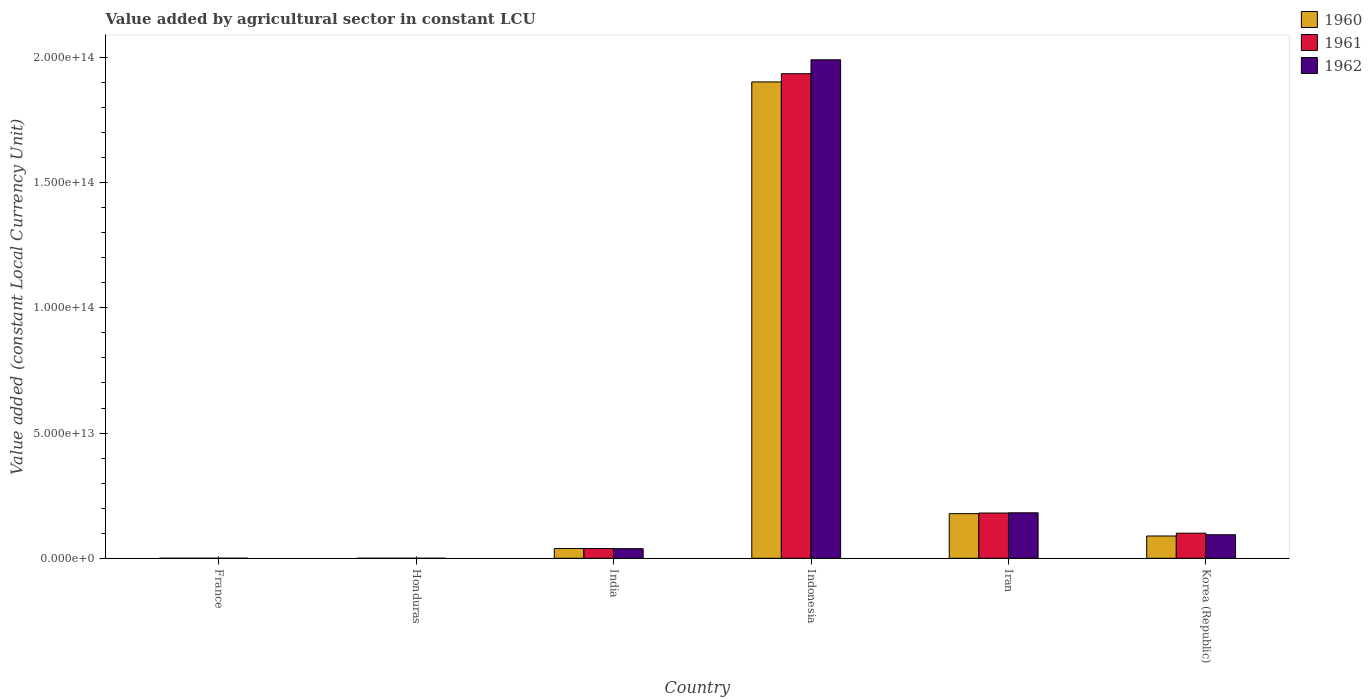How many different coloured bars are there?
Your answer should be compact. 3. How many bars are there on the 2nd tick from the right?
Give a very brief answer. 3. What is the value added by agricultural sector in 1960 in Korea (Republic)?
Keep it short and to the point. 8.90e+12. Across all countries, what is the maximum value added by agricultural sector in 1960?
Your answer should be very brief. 1.90e+14. Across all countries, what is the minimum value added by agricultural sector in 1962?
Provide a short and direct response. 4.96e+09. In which country was the value added by agricultural sector in 1961 minimum?
Keep it short and to the point. Honduras. What is the total value added by agricultural sector in 1961 in the graph?
Ensure brevity in your answer.  2.26e+14. What is the difference between the value added by agricultural sector in 1961 in Honduras and that in India?
Offer a very short reply. -3.90e+12. What is the difference between the value added by agricultural sector in 1961 in India and the value added by agricultural sector in 1960 in Honduras?
Give a very brief answer. 3.90e+12. What is the average value added by agricultural sector in 1961 per country?
Make the answer very short. 3.76e+13. What is the difference between the value added by agricultural sector of/in 1961 and value added by agricultural sector of/in 1962 in Honduras?
Your answer should be very brief. -2.25e+08. What is the ratio of the value added by agricultural sector in 1962 in France to that in Iran?
Offer a terse response. 0. Is the difference between the value added by agricultural sector in 1961 in Honduras and Iran greater than the difference between the value added by agricultural sector in 1962 in Honduras and Iran?
Your response must be concise. Yes. What is the difference between the highest and the second highest value added by agricultural sector in 1962?
Your answer should be very brief. -8.77e+12. What is the difference between the highest and the lowest value added by agricultural sector in 1960?
Make the answer very short. 1.90e+14. What does the 3rd bar from the right in India represents?
Offer a very short reply. 1960. Is it the case that in every country, the sum of the value added by agricultural sector in 1961 and value added by agricultural sector in 1962 is greater than the value added by agricultural sector in 1960?
Offer a terse response. Yes. How many countries are there in the graph?
Give a very brief answer. 6. What is the difference between two consecutive major ticks on the Y-axis?
Provide a succinct answer. 5.00e+13. Does the graph contain any zero values?
Your response must be concise. No. How are the legend labels stacked?
Ensure brevity in your answer.  Vertical. What is the title of the graph?
Keep it short and to the point. Value added by agricultural sector in constant LCU. What is the label or title of the Y-axis?
Offer a very short reply. Value added (constant Local Currency Unit). What is the Value added (constant Local Currency Unit) of 1960 in France?
Provide a short and direct response. 1.32e+1. What is the Value added (constant Local Currency Unit) in 1961 in France?
Offer a terse response. 1.25e+1. What is the Value added (constant Local Currency Unit) in 1962 in France?
Make the answer very short. 1.36e+1. What is the Value added (constant Local Currency Unit) in 1960 in Honduras?
Offer a very short reply. 4.44e+09. What is the Value added (constant Local Currency Unit) of 1961 in Honduras?
Keep it short and to the point. 4.73e+09. What is the Value added (constant Local Currency Unit) in 1962 in Honduras?
Provide a succinct answer. 4.96e+09. What is the Value added (constant Local Currency Unit) in 1960 in India?
Give a very brief answer. 3.90e+12. What is the Value added (constant Local Currency Unit) in 1961 in India?
Offer a very short reply. 3.91e+12. What is the Value added (constant Local Currency Unit) of 1962 in India?
Keep it short and to the point. 3.83e+12. What is the Value added (constant Local Currency Unit) of 1960 in Indonesia?
Give a very brief answer. 1.90e+14. What is the Value added (constant Local Currency Unit) of 1961 in Indonesia?
Keep it short and to the point. 1.94e+14. What is the Value added (constant Local Currency Unit) in 1962 in Indonesia?
Your response must be concise. 1.99e+14. What is the Value added (constant Local Currency Unit) in 1960 in Iran?
Your response must be concise. 1.78e+13. What is the Value added (constant Local Currency Unit) of 1961 in Iran?
Keep it short and to the point. 1.81e+13. What is the Value added (constant Local Currency Unit) of 1962 in Iran?
Keep it short and to the point. 1.82e+13. What is the Value added (constant Local Currency Unit) of 1960 in Korea (Republic)?
Provide a succinct answer. 8.90e+12. What is the Value added (constant Local Currency Unit) in 1961 in Korea (Republic)?
Your answer should be very brief. 1.00e+13. What is the Value added (constant Local Currency Unit) of 1962 in Korea (Republic)?
Keep it short and to the point. 9.39e+12. Across all countries, what is the maximum Value added (constant Local Currency Unit) in 1960?
Provide a succinct answer. 1.90e+14. Across all countries, what is the maximum Value added (constant Local Currency Unit) of 1961?
Your response must be concise. 1.94e+14. Across all countries, what is the maximum Value added (constant Local Currency Unit) of 1962?
Provide a short and direct response. 1.99e+14. Across all countries, what is the minimum Value added (constant Local Currency Unit) of 1960?
Provide a succinct answer. 4.44e+09. Across all countries, what is the minimum Value added (constant Local Currency Unit) of 1961?
Make the answer very short. 4.73e+09. Across all countries, what is the minimum Value added (constant Local Currency Unit) in 1962?
Make the answer very short. 4.96e+09. What is the total Value added (constant Local Currency Unit) in 1960 in the graph?
Provide a short and direct response. 2.21e+14. What is the total Value added (constant Local Currency Unit) in 1961 in the graph?
Offer a terse response. 2.26e+14. What is the total Value added (constant Local Currency Unit) of 1962 in the graph?
Make the answer very short. 2.30e+14. What is the difference between the Value added (constant Local Currency Unit) in 1960 in France and that in Honduras?
Ensure brevity in your answer.  8.72e+09. What is the difference between the Value added (constant Local Currency Unit) of 1961 in France and that in Honduras?
Offer a terse response. 7.74e+09. What is the difference between the Value added (constant Local Currency Unit) of 1962 in France and that in Honduras?
Keep it short and to the point. 8.63e+09. What is the difference between the Value added (constant Local Currency Unit) in 1960 in France and that in India?
Offer a terse response. -3.89e+12. What is the difference between the Value added (constant Local Currency Unit) of 1961 in France and that in India?
Make the answer very short. -3.90e+12. What is the difference between the Value added (constant Local Currency Unit) in 1962 in France and that in India?
Offer a very short reply. -3.82e+12. What is the difference between the Value added (constant Local Currency Unit) of 1960 in France and that in Indonesia?
Give a very brief answer. -1.90e+14. What is the difference between the Value added (constant Local Currency Unit) in 1961 in France and that in Indonesia?
Offer a very short reply. -1.94e+14. What is the difference between the Value added (constant Local Currency Unit) of 1962 in France and that in Indonesia?
Give a very brief answer. -1.99e+14. What is the difference between the Value added (constant Local Currency Unit) of 1960 in France and that in Iran?
Ensure brevity in your answer.  -1.78e+13. What is the difference between the Value added (constant Local Currency Unit) of 1961 in France and that in Iran?
Your response must be concise. -1.81e+13. What is the difference between the Value added (constant Local Currency Unit) in 1962 in France and that in Iran?
Give a very brief answer. -1.81e+13. What is the difference between the Value added (constant Local Currency Unit) in 1960 in France and that in Korea (Republic)?
Your response must be concise. -8.88e+12. What is the difference between the Value added (constant Local Currency Unit) of 1961 in France and that in Korea (Republic)?
Provide a short and direct response. -1.00e+13. What is the difference between the Value added (constant Local Currency Unit) in 1962 in France and that in Korea (Republic)?
Offer a terse response. -9.38e+12. What is the difference between the Value added (constant Local Currency Unit) in 1960 in Honduras and that in India?
Ensure brevity in your answer.  -3.90e+12. What is the difference between the Value added (constant Local Currency Unit) of 1961 in Honduras and that in India?
Your answer should be compact. -3.90e+12. What is the difference between the Value added (constant Local Currency Unit) in 1962 in Honduras and that in India?
Keep it short and to the point. -3.82e+12. What is the difference between the Value added (constant Local Currency Unit) in 1960 in Honduras and that in Indonesia?
Provide a succinct answer. -1.90e+14. What is the difference between the Value added (constant Local Currency Unit) in 1961 in Honduras and that in Indonesia?
Provide a succinct answer. -1.94e+14. What is the difference between the Value added (constant Local Currency Unit) in 1962 in Honduras and that in Indonesia?
Your answer should be very brief. -1.99e+14. What is the difference between the Value added (constant Local Currency Unit) in 1960 in Honduras and that in Iran?
Your response must be concise. -1.78e+13. What is the difference between the Value added (constant Local Currency Unit) of 1961 in Honduras and that in Iran?
Provide a short and direct response. -1.81e+13. What is the difference between the Value added (constant Local Currency Unit) of 1962 in Honduras and that in Iran?
Your answer should be compact. -1.82e+13. What is the difference between the Value added (constant Local Currency Unit) in 1960 in Honduras and that in Korea (Republic)?
Offer a very short reply. -8.89e+12. What is the difference between the Value added (constant Local Currency Unit) of 1961 in Honduras and that in Korea (Republic)?
Your answer should be very brief. -1.00e+13. What is the difference between the Value added (constant Local Currency Unit) of 1962 in Honduras and that in Korea (Republic)?
Your answer should be very brief. -9.39e+12. What is the difference between the Value added (constant Local Currency Unit) of 1960 in India and that in Indonesia?
Give a very brief answer. -1.86e+14. What is the difference between the Value added (constant Local Currency Unit) of 1961 in India and that in Indonesia?
Your response must be concise. -1.90e+14. What is the difference between the Value added (constant Local Currency Unit) in 1962 in India and that in Indonesia?
Provide a short and direct response. -1.95e+14. What is the difference between the Value added (constant Local Currency Unit) of 1960 in India and that in Iran?
Ensure brevity in your answer.  -1.39e+13. What is the difference between the Value added (constant Local Currency Unit) in 1961 in India and that in Iran?
Your answer should be compact. -1.42e+13. What is the difference between the Value added (constant Local Currency Unit) of 1962 in India and that in Iran?
Your answer should be compact. -1.43e+13. What is the difference between the Value added (constant Local Currency Unit) in 1960 in India and that in Korea (Republic)?
Make the answer very short. -4.99e+12. What is the difference between the Value added (constant Local Currency Unit) of 1961 in India and that in Korea (Republic)?
Your answer should be compact. -6.11e+12. What is the difference between the Value added (constant Local Currency Unit) in 1962 in India and that in Korea (Republic)?
Provide a short and direct response. -5.56e+12. What is the difference between the Value added (constant Local Currency Unit) in 1960 in Indonesia and that in Iran?
Your response must be concise. 1.72e+14. What is the difference between the Value added (constant Local Currency Unit) of 1961 in Indonesia and that in Iran?
Your answer should be very brief. 1.75e+14. What is the difference between the Value added (constant Local Currency Unit) in 1962 in Indonesia and that in Iran?
Offer a terse response. 1.81e+14. What is the difference between the Value added (constant Local Currency Unit) in 1960 in Indonesia and that in Korea (Republic)?
Give a very brief answer. 1.81e+14. What is the difference between the Value added (constant Local Currency Unit) of 1961 in Indonesia and that in Korea (Republic)?
Your answer should be very brief. 1.83e+14. What is the difference between the Value added (constant Local Currency Unit) in 1962 in Indonesia and that in Korea (Republic)?
Offer a very short reply. 1.90e+14. What is the difference between the Value added (constant Local Currency Unit) in 1960 in Iran and that in Korea (Republic)?
Your answer should be very brief. 8.93e+12. What is the difference between the Value added (constant Local Currency Unit) in 1961 in Iran and that in Korea (Republic)?
Your answer should be compact. 8.05e+12. What is the difference between the Value added (constant Local Currency Unit) of 1962 in Iran and that in Korea (Republic)?
Offer a very short reply. 8.77e+12. What is the difference between the Value added (constant Local Currency Unit) of 1960 in France and the Value added (constant Local Currency Unit) of 1961 in Honduras?
Keep it short and to the point. 8.43e+09. What is the difference between the Value added (constant Local Currency Unit) in 1960 in France and the Value added (constant Local Currency Unit) in 1962 in Honduras?
Ensure brevity in your answer.  8.20e+09. What is the difference between the Value added (constant Local Currency Unit) in 1961 in France and the Value added (constant Local Currency Unit) in 1962 in Honduras?
Your response must be concise. 7.52e+09. What is the difference between the Value added (constant Local Currency Unit) in 1960 in France and the Value added (constant Local Currency Unit) in 1961 in India?
Your answer should be very brief. -3.89e+12. What is the difference between the Value added (constant Local Currency Unit) of 1960 in France and the Value added (constant Local Currency Unit) of 1962 in India?
Provide a short and direct response. -3.82e+12. What is the difference between the Value added (constant Local Currency Unit) in 1961 in France and the Value added (constant Local Currency Unit) in 1962 in India?
Give a very brief answer. -3.82e+12. What is the difference between the Value added (constant Local Currency Unit) in 1960 in France and the Value added (constant Local Currency Unit) in 1961 in Indonesia?
Ensure brevity in your answer.  -1.94e+14. What is the difference between the Value added (constant Local Currency Unit) of 1960 in France and the Value added (constant Local Currency Unit) of 1962 in Indonesia?
Ensure brevity in your answer.  -1.99e+14. What is the difference between the Value added (constant Local Currency Unit) of 1961 in France and the Value added (constant Local Currency Unit) of 1962 in Indonesia?
Provide a succinct answer. -1.99e+14. What is the difference between the Value added (constant Local Currency Unit) in 1960 in France and the Value added (constant Local Currency Unit) in 1961 in Iran?
Your answer should be compact. -1.81e+13. What is the difference between the Value added (constant Local Currency Unit) of 1960 in France and the Value added (constant Local Currency Unit) of 1962 in Iran?
Give a very brief answer. -1.81e+13. What is the difference between the Value added (constant Local Currency Unit) in 1961 in France and the Value added (constant Local Currency Unit) in 1962 in Iran?
Provide a succinct answer. -1.81e+13. What is the difference between the Value added (constant Local Currency Unit) in 1960 in France and the Value added (constant Local Currency Unit) in 1961 in Korea (Republic)?
Offer a very short reply. -1.00e+13. What is the difference between the Value added (constant Local Currency Unit) in 1960 in France and the Value added (constant Local Currency Unit) in 1962 in Korea (Republic)?
Your answer should be compact. -9.38e+12. What is the difference between the Value added (constant Local Currency Unit) in 1961 in France and the Value added (constant Local Currency Unit) in 1962 in Korea (Republic)?
Your answer should be very brief. -9.38e+12. What is the difference between the Value added (constant Local Currency Unit) in 1960 in Honduras and the Value added (constant Local Currency Unit) in 1961 in India?
Your response must be concise. -3.90e+12. What is the difference between the Value added (constant Local Currency Unit) of 1960 in Honduras and the Value added (constant Local Currency Unit) of 1962 in India?
Give a very brief answer. -3.83e+12. What is the difference between the Value added (constant Local Currency Unit) of 1961 in Honduras and the Value added (constant Local Currency Unit) of 1962 in India?
Ensure brevity in your answer.  -3.83e+12. What is the difference between the Value added (constant Local Currency Unit) in 1960 in Honduras and the Value added (constant Local Currency Unit) in 1961 in Indonesia?
Offer a terse response. -1.94e+14. What is the difference between the Value added (constant Local Currency Unit) in 1960 in Honduras and the Value added (constant Local Currency Unit) in 1962 in Indonesia?
Offer a terse response. -1.99e+14. What is the difference between the Value added (constant Local Currency Unit) of 1961 in Honduras and the Value added (constant Local Currency Unit) of 1962 in Indonesia?
Your answer should be compact. -1.99e+14. What is the difference between the Value added (constant Local Currency Unit) of 1960 in Honduras and the Value added (constant Local Currency Unit) of 1961 in Iran?
Your response must be concise. -1.81e+13. What is the difference between the Value added (constant Local Currency Unit) of 1960 in Honduras and the Value added (constant Local Currency Unit) of 1962 in Iran?
Offer a very short reply. -1.82e+13. What is the difference between the Value added (constant Local Currency Unit) in 1961 in Honduras and the Value added (constant Local Currency Unit) in 1962 in Iran?
Offer a terse response. -1.82e+13. What is the difference between the Value added (constant Local Currency Unit) in 1960 in Honduras and the Value added (constant Local Currency Unit) in 1961 in Korea (Republic)?
Offer a terse response. -1.00e+13. What is the difference between the Value added (constant Local Currency Unit) of 1960 in Honduras and the Value added (constant Local Currency Unit) of 1962 in Korea (Republic)?
Your response must be concise. -9.39e+12. What is the difference between the Value added (constant Local Currency Unit) in 1961 in Honduras and the Value added (constant Local Currency Unit) in 1962 in Korea (Republic)?
Keep it short and to the point. -9.39e+12. What is the difference between the Value added (constant Local Currency Unit) of 1960 in India and the Value added (constant Local Currency Unit) of 1961 in Indonesia?
Make the answer very short. -1.90e+14. What is the difference between the Value added (constant Local Currency Unit) of 1960 in India and the Value added (constant Local Currency Unit) of 1962 in Indonesia?
Offer a terse response. -1.95e+14. What is the difference between the Value added (constant Local Currency Unit) of 1961 in India and the Value added (constant Local Currency Unit) of 1962 in Indonesia?
Your response must be concise. -1.95e+14. What is the difference between the Value added (constant Local Currency Unit) of 1960 in India and the Value added (constant Local Currency Unit) of 1961 in Iran?
Your answer should be very brief. -1.42e+13. What is the difference between the Value added (constant Local Currency Unit) of 1960 in India and the Value added (constant Local Currency Unit) of 1962 in Iran?
Your answer should be very brief. -1.43e+13. What is the difference between the Value added (constant Local Currency Unit) in 1961 in India and the Value added (constant Local Currency Unit) in 1962 in Iran?
Your answer should be very brief. -1.43e+13. What is the difference between the Value added (constant Local Currency Unit) in 1960 in India and the Value added (constant Local Currency Unit) in 1961 in Korea (Republic)?
Your answer should be very brief. -6.12e+12. What is the difference between the Value added (constant Local Currency Unit) in 1960 in India and the Value added (constant Local Currency Unit) in 1962 in Korea (Republic)?
Your answer should be very brief. -5.49e+12. What is the difference between the Value added (constant Local Currency Unit) in 1961 in India and the Value added (constant Local Currency Unit) in 1962 in Korea (Republic)?
Keep it short and to the point. -5.48e+12. What is the difference between the Value added (constant Local Currency Unit) of 1960 in Indonesia and the Value added (constant Local Currency Unit) of 1961 in Iran?
Make the answer very short. 1.72e+14. What is the difference between the Value added (constant Local Currency Unit) of 1960 in Indonesia and the Value added (constant Local Currency Unit) of 1962 in Iran?
Provide a short and direct response. 1.72e+14. What is the difference between the Value added (constant Local Currency Unit) in 1961 in Indonesia and the Value added (constant Local Currency Unit) in 1962 in Iran?
Your answer should be compact. 1.75e+14. What is the difference between the Value added (constant Local Currency Unit) of 1960 in Indonesia and the Value added (constant Local Currency Unit) of 1961 in Korea (Republic)?
Provide a short and direct response. 1.80e+14. What is the difference between the Value added (constant Local Currency Unit) in 1960 in Indonesia and the Value added (constant Local Currency Unit) in 1962 in Korea (Republic)?
Offer a terse response. 1.81e+14. What is the difference between the Value added (constant Local Currency Unit) of 1961 in Indonesia and the Value added (constant Local Currency Unit) of 1962 in Korea (Republic)?
Ensure brevity in your answer.  1.84e+14. What is the difference between the Value added (constant Local Currency Unit) of 1960 in Iran and the Value added (constant Local Currency Unit) of 1961 in Korea (Republic)?
Give a very brief answer. 7.81e+12. What is the difference between the Value added (constant Local Currency Unit) in 1960 in Iran and the Value added (constant Local Currency Unit) in 1962 in Korea (Republic)?
Your answer should be very brief. 8.44e+12. What is the difference between the Value added (constant Local Currency Unit) of 1961 in Iran and the Value added (constant Local Currency Unit) of 1962 in Korea (Republic)?
Ensure brevity in your answer.  8.68e+12. What is the average Value added (constant Local Currency Unit) in 1960 per country?
Provide a succinct answer. 3.68e+13. What is the average Value added (constant Local Currency Unit) of 1961 per country?
Your response must be concise. 3.76e+13. What is the average Value added (constant Local Currency Unit) in 1962 per country?
Provide a short and direct response. 3.84e+13. What is the difference between the Value added (constant Local Currency Unit) in 1960 and Value added (constant Local Currency Unit) in 1961 in France?
Your answer should be compact. 6.84e+08. What is the difference between the Value added (constant Local Currency Unit) in 1960 and Value added (constant Local Currency Unit) in 1962 in France?
Offer a terse response. -4.23e+08. What is the difference between the Value added (constant Local Currency Unit) in 1961 and Value added (constant Local Currency Unit) in 1962 in France?
Give a very brief answer. -1.11e+09. What is the difference between the Value added (constant Local Currency Unit) in 1960 and Value added (constant Local Currency Unit) in 1961 in Honduras?
Ensure brevity in your answer.  -2.90e+08. What is the difference between the Value added (constant Local Currency Unit) of 1960 and Value added (constant Local Currency Unit) of 1962 in Honduras?
Your answer should be compact. -5.15e+08. What is the difference between the Value added (constant Local Currency Unit) in 1961 and Value added (constant Local Currency Unit) in 1962 in Honduras?
Offer a terse response. -2.25e+08. What is the difference between the Value added (constant Local Currency Unit) of 1960 and Value added (constant Local Currency Unit) of 1961 in India?
Your response must be concise. -3.29e+09. What is the difference between the Value added (constant Local Currency Unit) of 1960 and Value added (constant Local Currency Unit) of 1962 in India?
Provide a succinct answer. 7.44e+1. What is the difference between the Value added (constant Local Currency Unit) in 1961 and Value added (constant Local Currency Unit) in 1962 in India?
Keep it short and to the point. 7.77e+1. What is the difference between the Value added (constant Local Currency Unit) in 1960 and Value added (constant Local Currency Unit) in 1961 in Indonesia?
Your answer should be very brief. -3.27e+12. What is the difference between the Value added (constant Local Currency Unit) in 1960 and Value added (constant Local Currency Unit) in 1962 in Indonesia?
Your answer should be very brief. -8.83e+12. What is the difference between the Value added (constant Local Currency Unit) in 1961 and Value added (constant Local Currency Unit) in 1962 in Indonesia?
Ensure brevity in your answer.  -5.56e+12. What is the difference between the Value added (constant Local Currency Unit) of 1960 and Value added (constant Local Currency Unit) of 1961 in Iran?
Offer a terse response. -2.42e+11. What is the difference between the Value added (constant Local Currency Unit) of 1960 and Value added (constant Local Currency Unit) of 1962 in Iran?
Ensure brevity in your answer.  -3.32e+11. What is the difference between the Value added (constant Local Currency Unit) in 1961 and Value added (constant Local Currency Unit) in 1962 in Iran?
Provide a short and direct response. -8.95e+1. What is the difference between the Value added (constant Local Currency Unit) of 1960 and Value added (constant Local Currency Unit) of 1961 in Korea (Republic)?
Keep it short and to the point. -1.12e+12. What is the difference between the Value added (constant Local Currency Unit) in 1960 and Value added (constant Local Currency Unit) in 1962 in Korea (Republic)?
Make the answer very short. -4.93e+11. What is the difference between the Value added (constant Local Currency Unit) of 1961 and Value added (constant Local Currency Unit) of 1962 in Korea (Republic)?
Give a very brief answer. 6.31e+11. What is the ratio of the Value added (constant Local Currency Unit) of 1960 in France to that in Honduras?
Offer a terse response. 2.96. What is the ratio of the Value added (constant Local Currency Unit) in 1961 in France to that in Honduras?
Your answer should be compact. 2.64. What is the ratio of the Value added (constant Local Currency Unit) of 1962 in France to that in Honduras?
Your answer should be compact. 2.74. What is the ratio of the Value added (constant Local Currency Unit) in 1960 in France to that in India?
Give a very brief answer. 0. What is the ratio of the Value added (constant Local Currency Unit) in 1961 in France to that in India?
Ensure brevity in your answer.  0. What is the ratio of the Value added (constant Local Currency Unit) of 1962 in France to that in India?
Keep it short and to the point. 0. What is the ratio of the Value added (constant Local Currency Unit) in 1960 in France to that in Indonesia?
Your response must be concise. 0. What is the ratio of the Value added (constant Local Currency Unit) in 1960 in France to that in Iran?
Ensure brevity in your answer.  0. What is the ratio of the Value added (constant Local Currency Unit) of 1961 in France to that in Iran?
Keep it short and to the point. 0. What is the ratio of the Value added (constant Local Currency Unit) in 1962 in France to that in Iran?
Keep it short and to the point. 0. What is the ratio of the Value added (constant Local Currency Unit) of 1960 in France to that in Korea (Republic)?
Offer a very short reply. 0. What is the ratio of the Value added (constant Local Currency Unit) of 1961 in France to that in Korea (Republic)?
Make the answer very short. 0. What is the ratio of the Value added (constant Local Currency Unit) in 1962 in France to that in Korea (Republic)?
Offer a terse response. 0. What is the ratio of the Value added (constant Local Currency Unit) of 1960 in Honduras to that in India?
Your answer should be compact. 0. What is the ratio of the Value added (constant Local Currency Unit) in 1961 in Honduras to that in India?
Make the answer very short. 0. What is the ratio of the Value added (constant Local Currency Unit) of 1962 in Honduras to that in India?
Keep it short and to the point. 0. What is the ratio of the Value added (constant Local Currency Unit) of 1961 in Honduras to that in Indonesia?
Provide a succinct answer. 0. What is the ratio of the Value added (constant Local Currency Unit) in 1962 in Honduras to that in Indonesia?
Offer a very short reply. 0. What is the ratio of the Value added (constant Local Currency Unit) of 1960 in Honduras to that in Iran?
Your answer should be compact. 0. What is the ratio of the Value added (constant Local Currency Unit) in 1960 in Honduras to that in Korea (Republic)?
Provide a succinct answer. 0. What is the ratio of the Value added (constant Local Currency Unit) in 1962 in Honduras to that in Korea (Republic)?
Provide a short and direct response. 0. What is the ratio of the Value added (constant Local Currency Unit) of 1960 in India to that in Indonesia?
Make the answer very short. 0.02. What is the ratio of the Value added (constant Local Currency Unit) in 1961 in India to that in Indonesia?
Keep it short and to the point. 0.02. What is the ratio of the Value added (constant Local Currency Unit) in 1962 in India to that in Indonesia?
Ensure brevity in your answer.  0.02. What is the ratio of the Value added (constant Local Currency Unit) of 1960 in India to that in Iran?
Your answer should be very brief. 0.22. What is the ratio of the Value added (constant Local Currency Unit) of 1961 in India to that in Iran?
Your answer should be compact. 0.22. What is the ratio of the Value added (constant Local Currency Unit) of 1962 in India to that in Iran?
Your response must be concise. 0.21. What is the ratio of the Value added (constant Local Currency Unit) of 1960 in India to that in Korea (Republic)?
Your answer should be compact. 0.44. What is the ratio of the Value added (constant Local Currency Unit) of 1961 in India to that in Korea (Republic)?
Give a very brief answer. 0.39. What is the ratio of the Value added (constant Local Currency Unit) of 1962 in India to that in Korea (Republic)?
Provide a succinct answer. 0.41. What is the ratio of the Value added (constant Local Currency Unit) in 1960 in Indonesia to that in Iran?
Provide a succinct answer. 10.67. What is the ratio of the Value added (constant Local Currency Unit) in 1961 in Indonesia to that in Iran?
Provide a short and direct response. 10.71. What is the ratio of the Value added (constant Local Currency Unit) of 1962 in Indonesia to that in Iran?
Your answer should be very brief. 10.96. What is the ratio of the Value added (constant Local Currency Unit) in 1960 in Indonesia to that in Korea (Republic)?
Make the answer very short. 21.38. What is the ratio of the Value added (constant Local Currency Unit) in 1961 in Indonesia to that in Korea (Republic)?
Your answer should be compact. 19.31. What is the ratio of the Value added (constant Local Currency Unit) of 1962 in Indonesia to that in Korea (Republic)?
Provide a succinct answer. 21.2. What is the ratio of the Value added (constant Local Currency Unit) in 1960 in Iran to that in Korea (Republic)?
Your answer should be very brief. 2. What is the ratio of the Value added (constant Local Currency Unit) of 1961 in Iran to that in Korea (Republic)?
Ensure brevity in your answer.  1.8. What is the ratio of the Value added (constant Local Currency Unit) in 1962 in Iran to that in Korea (Republic)?
Offer a terse response. 1.93. What is the difference between the highest and the second highest Value added (constant Local Currency Unit) of 1960?
Keep it short and to the point. 1.72e+14. What is the difference between the highest and the second highest Value added (constant Local Currency Unit) of 1961?
Give a very brief answer. 1.75e+14. What is the difference between the highest and the second highest Value added (constant Local Currency Unit) in 1962?
Your response must be concise. 1.81e+14. What is the difference between the highest and the lowest Value added (constant Local Currency Unit) of 1960?
Make the answer very short. 1.90e+14. What is the difference between the highest and the lowest Value added (constant Local Currency Unit) in 1961?
Your response must be concise. 1.94e+14. What is the difference between the highest and the lowest Value added (constant Local Currency Unit) of 1962?
Your answer should be very brief. 1.99e+14. 